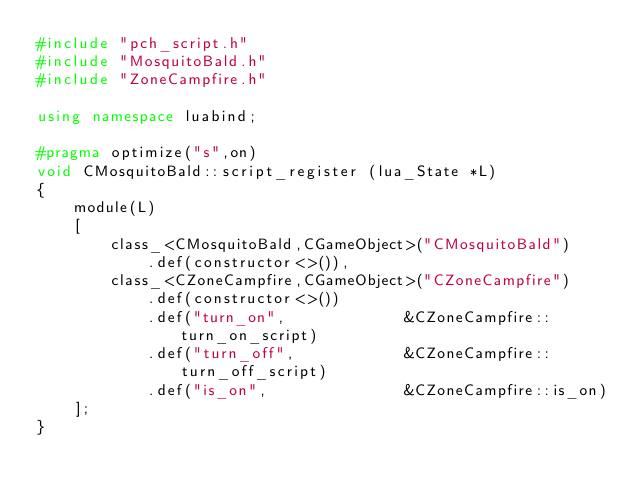Convert code to text. <code><loc_0><loc_0><loc_500><loc_500><_C++_>#include "pch_script.h"
#include "MosquitoBald.h"
#include "ZoneCampfire.h"

using namespace luabind;

#pragma optimize("s",on)
void CMosquitoBald::script_register	(lua_State *L)
{
	module(L)
	[
		class_<CMosquitoBald,CGameObject>("CMosquitoBald")
			.def(constructor<>()),
		class_<CZoneCampfire,CGameObject>("CZoneCampfire")
			.def(constructor<>())
			.def("turn_on",				&CZoneCampfire::turn_on_script)
			.def("turn_off",			&CZoneCampfire::turn_off_script)
			.def("is_on",				&CZoneCampfire::is_on)
	];
}
</code> 